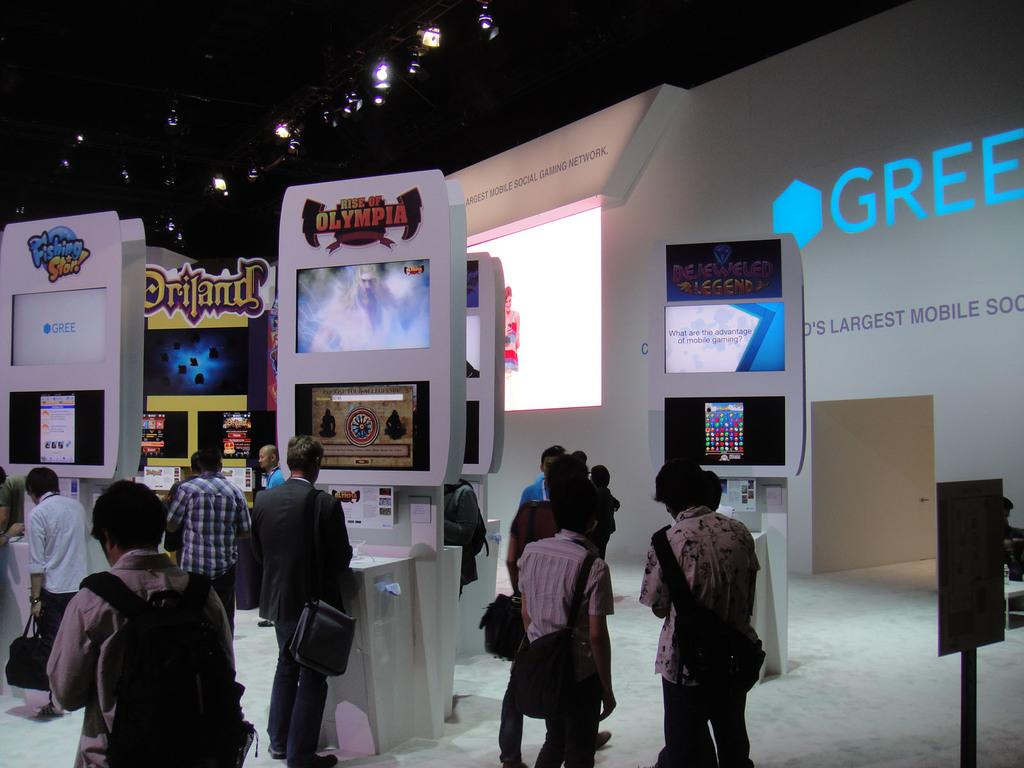How many people are in the image? There are many people in the image. What are the people doing in the image? The people are standing in front of gaming boards. What can be seen in the background of the image? There is a projector in the background of the image. What is written on the projector? The word "GREEN" is written on the projector. Can you see an owl perched on the gaming board in the image? No, there is no owl present in the image. What attraction is the group of people gathered around in the image? The provided facts do not mention any specific attraction; the people are simply standing in front of gaming boards. 